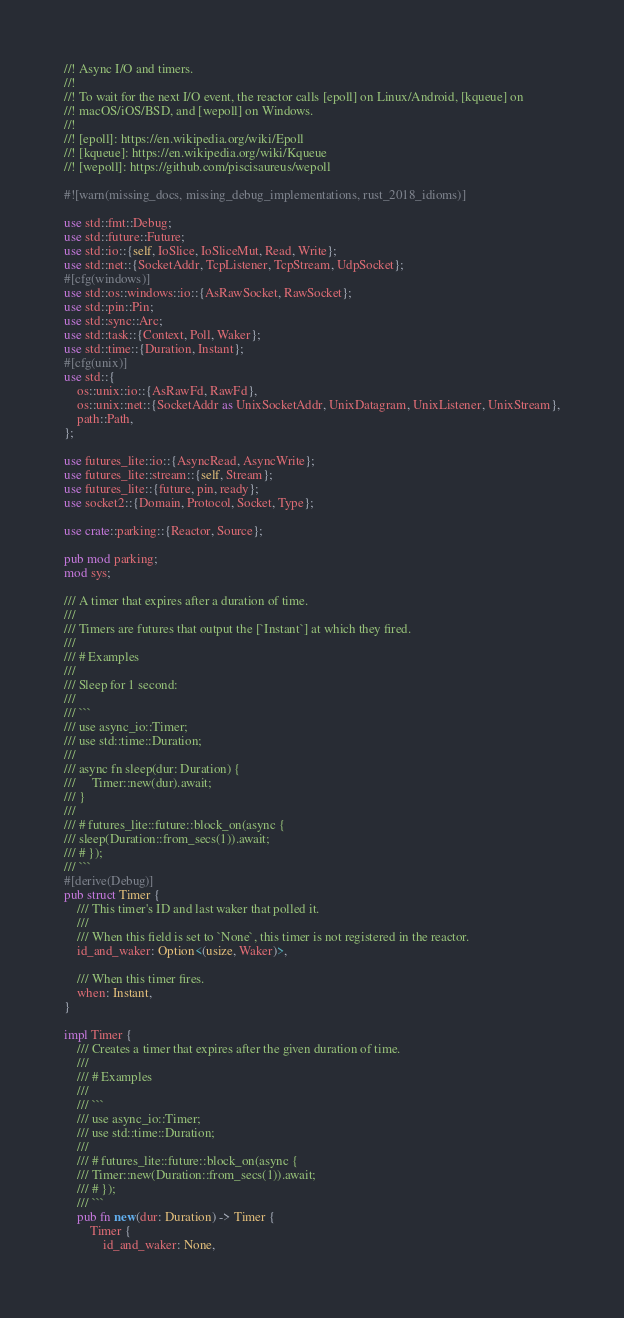Convert code to text. <code><loc_0><loc_0><loc_500><loc_500><_Rust_>//! Async I/O and timers.
//!
//! To wait for the next I/O event, the reactor calls [epoll] on Linux/Android, [kqueue] on
//! macOS/iOS/BSD, and [wepoll] on Windows.
//!
//! [epoll]: https://en.wikipedia.org/wiki/Epoll
//! [kqueue]: https://en.wikipedia.org/wiki/Kqueue
//! [wepoll]: https://github.com/piscisaureus/wepoll

#![warn(missing_docs, missing_debug_implementations, rust_2018_idioms)]

use std::fmt::Debug;
use std::future::Future;
use std::io::{self, IoSlice, IoSliceMut, Read, Write};
use std::net::{SocketAddr, TcpListener, TcpStream, UdpSocket};
#[cfg(windows)]
use std::os::windows::io::{AsRawSocket, RawSocket};
use std::pin::Pin;
use std::sync::Arc;
use std::task::{Context, Poll, Waker};
use std::time::{Duration, Instant};
#[cfg(unix)]
use std::{
    os::unix::io::{AsRawFd, RawFd},
    os::unix::net::{SocketAddr as UnixSocketAddr, UnixDatagram, UnixListener, UnixStream},
    path::Path,
};

use futures_lite::io::{AsyncRead, AsyncWrite};
use futures_lite::stream::{self, Stream};
use futures_lite::{future, pin, ready};
use socket2::{Domain, Protocol, Socket, Type};

use crate::parking::{Reactor, Source};

pub mod parking;
mod sys;

/// A timer that expires after a duration of time.
///
/// Timers are futures that output the [`Instant`] at which they fired.
///
/// # Examples
///
/// Sleep for 1 second:
///
/// ```
/// use async_io::Timer;
/// use std::time::Duration;
///
/// async fn sleep(dur: Duration) {
///     Timer::new(dur).await;
/// }
///
/// # futures_lite::future::block_on(async {
/// sleep(Duration::from_secs(1)).await;
/// # });
/// ```
#[derive(Debug)]
pub struct Timer {
    /// This timer's ID and last waker that polled it.
    ///
    /// When this field is set to `None`, this timer is not registered in the reactor.
    id_and_waker: Option<(usize, Waker)>,

    /// When this timer fires.
    when: Instant,
}

impl Timer {
    /// Creates a timer that expires after the given duration of time.
    ///
    /// # Examples
    ///
    /// ```
    /// use async_io::Timer;
    /// use std::time::Duration;
    ///
    /// # futures_lite::future::block_on(async {
    /// Timer::new(Duration::from_secs(1)).await;
    /// # });
    /// ```
    pub fn new(dur: Duration) -> Timer {
        Timer {
            id_and_waker: None,</code> 